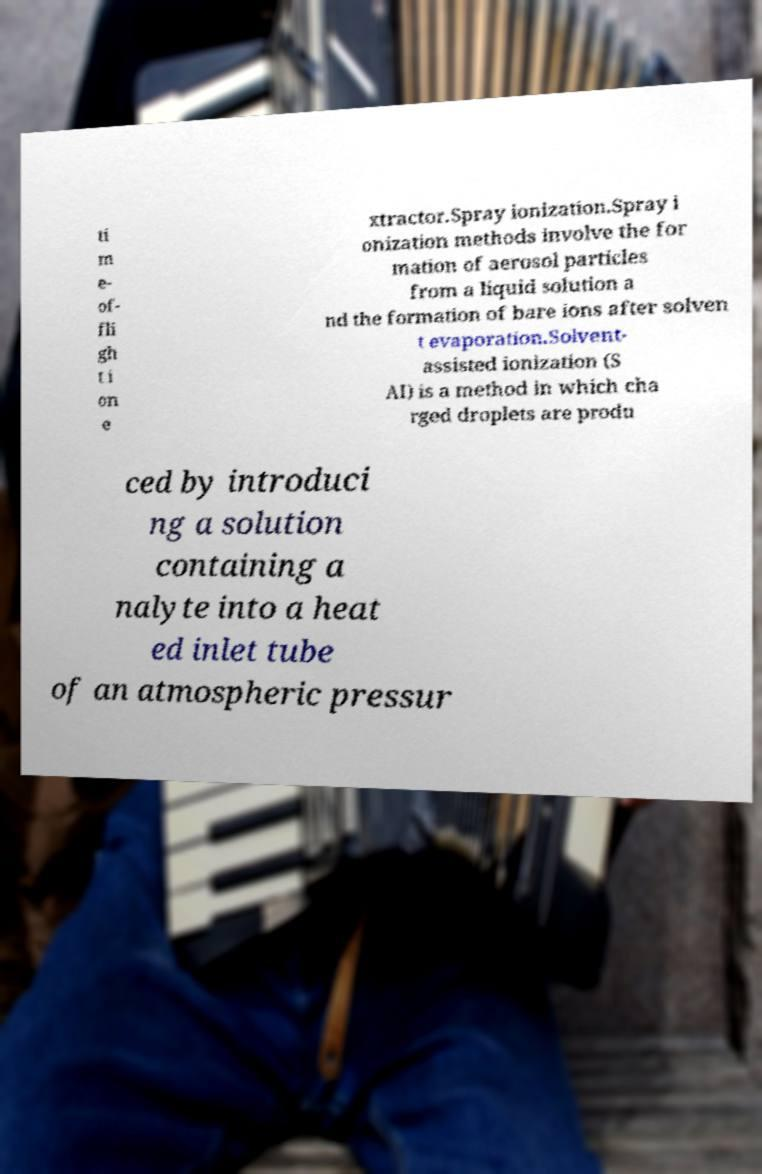For documentation purposes, I need the text within this image transcribed. Could you provide that? ti m e- of- fli gh t i on e xtractor.Spray ionization.Spray i onization methods involve the for mation of aerosol particles from a liquid solution a nd the formation of bare ions after solven t evaporation.Solvent- assisted ionization (S AI) is a method in which cha rged droplets are produ ced by introduci ng a solution containing a nalyte into a heat ed inlet tube of an atmospheric pressur 